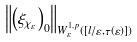Convert formula to latex. <formula><loc_0><loc_0><loc_500><loc_500>\left \| \left ( \xi _ { \chi _ { \varepsilon } } \right ) _ { 0 } \right \| _ { W _ { \varepsilon } ^ { 1 , p } \left ( [ l / \varepsilon , \tau ( \varepsilon ) ] \right ) }</formula> 